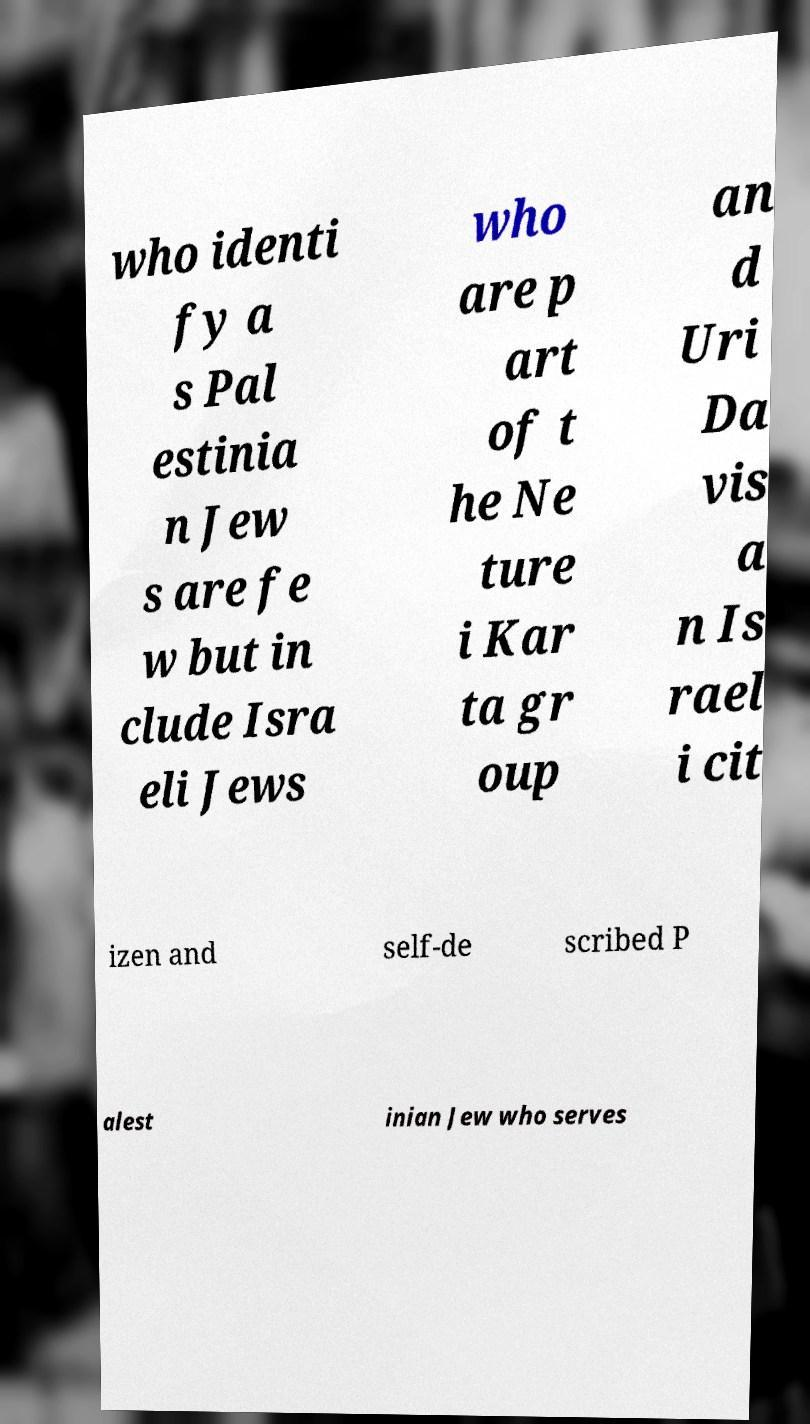There's text embedded in this image that I need extracted. Can you transcribe it verbatim? who identi fy a s Pal estinia n Jew s are fe w but in clude Isra eli Jews who are p art of t he Ne ture i Kar ta gr oup an d Uri Da vis a n Is rael i cit izen and self-de scribed P alest inian Jew who serves 